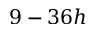Convert formula to latex. <formula><loc_0><loc_0><loc_500><loc_500>9 - 3 6 h</formula> 